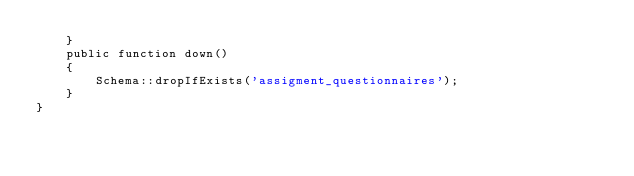<code> <loc_0><loc_0><loc_500><loc_500><_PHP_>    }
    public function down()
    {
        Schema::dropIfExists('assigment_questionnaires');
    }
}
</code> 